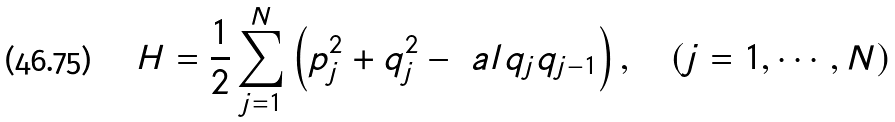Convert formula to latex. <formula><loc_0><loc_0><loc_500><loc_500>H = \frac { 1 } { 2 } \sum _ { j = 1 } ^ { N } \left ( p _ { j } ^ { 2 } + q _ { j } ^ { 2 } - \ a l q _ { j } q _ { j - 1 } \right ) , \quad ( j = 1 , \cdots , N )</formula> 